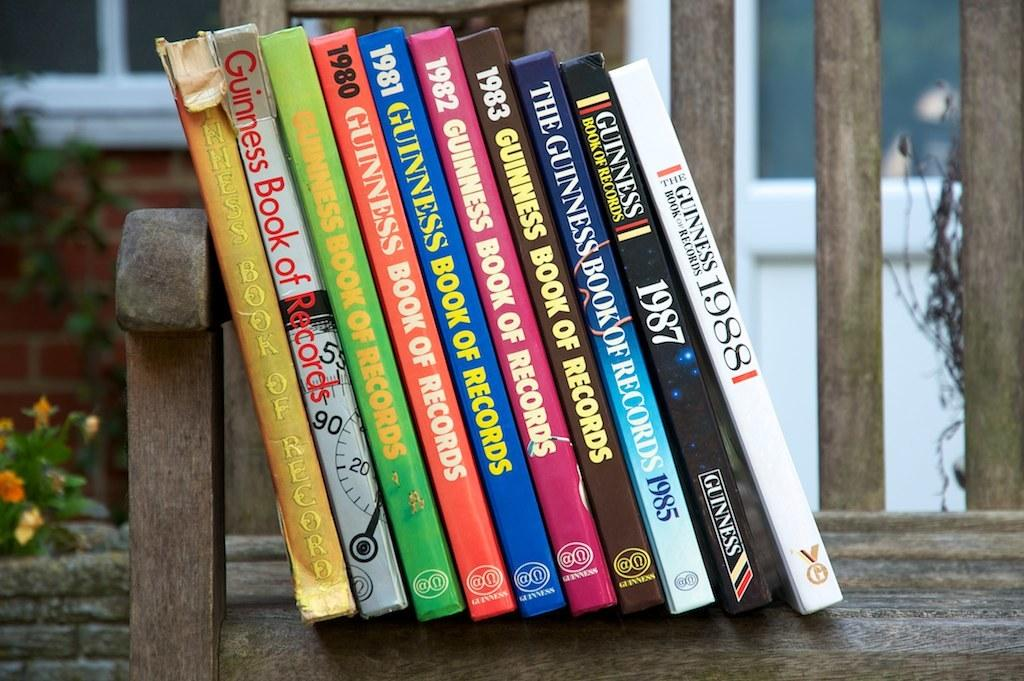Provide a one-sentence caption for the provided image. The books stacked on the bench are copies of the Guinness Book of Records from the 1980s and 1990s. 